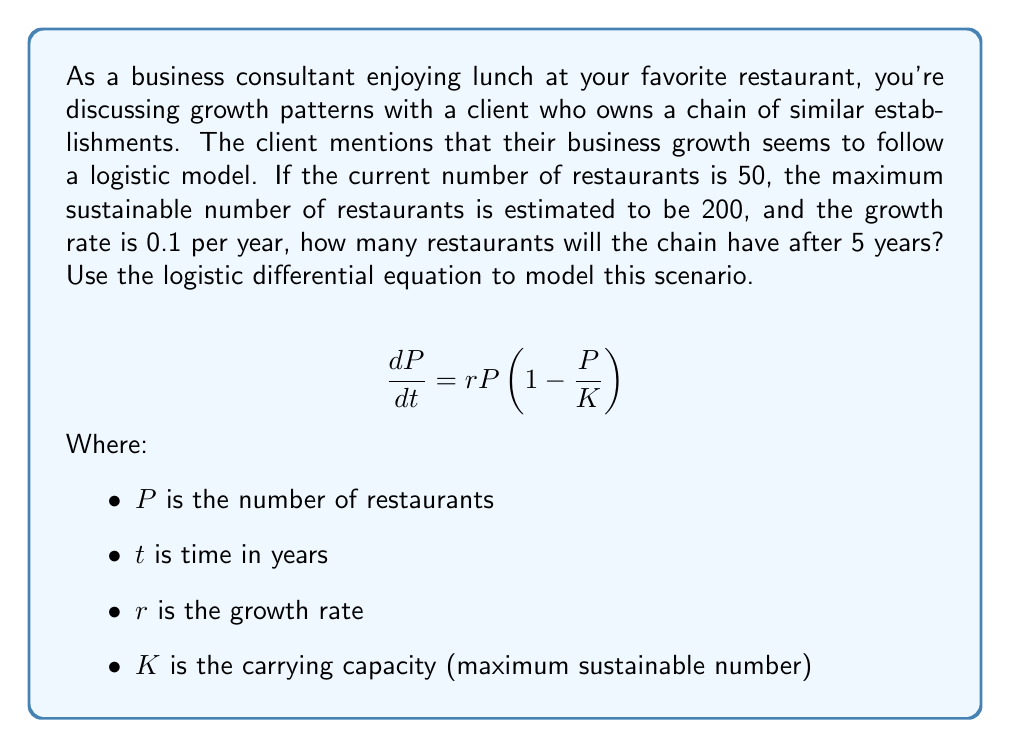Show me your answer to this math problem. To solve this problem, we'll use the logistic growth model, which is described by the differential equation:

$$\frac{dP}{dt} = rP(1-\frac{P}{K})$$

Given:
- Initial number of restaurants, $P_0 = 50$
- Carrying capacity, $K = 200$
- Growth rate, $r = 0.1$ per year
- Time period, $t = 5$ years

The solution to the logistic differential equation is:

$$P(t) = \frac{KP_0}{P_0 + (K-P_0)e^{-rt}}$$

Let's substitute the given values:

$$P(5) = \frac{200 \cdot 50}{50 + (200-50)e^{-0.1 \cdot 5}}$$

$$P(5) = \frac{10000}{50 + 150e^{-0.5}}$$

Now, let's calculate this step-by-step:

1. Calculate $e^{-0.5}$:
   $e^{-0.5} \approx 0.6065$

2. Multiply by 150:
   $150 \cdot 0.6065 \approx 90.975$

3. Add 50:
   $50 + 90.975 = 140.975$

4. Divide 10000 by this result:
   $\frac{10000}{140.975} \approx 70.93$

5. Round to the nearest whole number (as we can't have a fraction of a restaurant):
   $71$ restaurants

Therefore, after 5 years, the chain will have approximately 71 restaurants.
Answer: 71 restaurants 